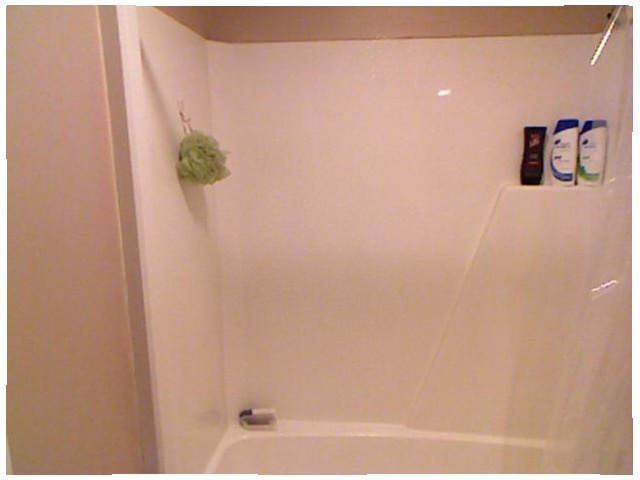<image>
Is the sponge on the wall? Yes. Looking at the image, I can see the sponge is positioned on top of the wall, with the wall providing support. 